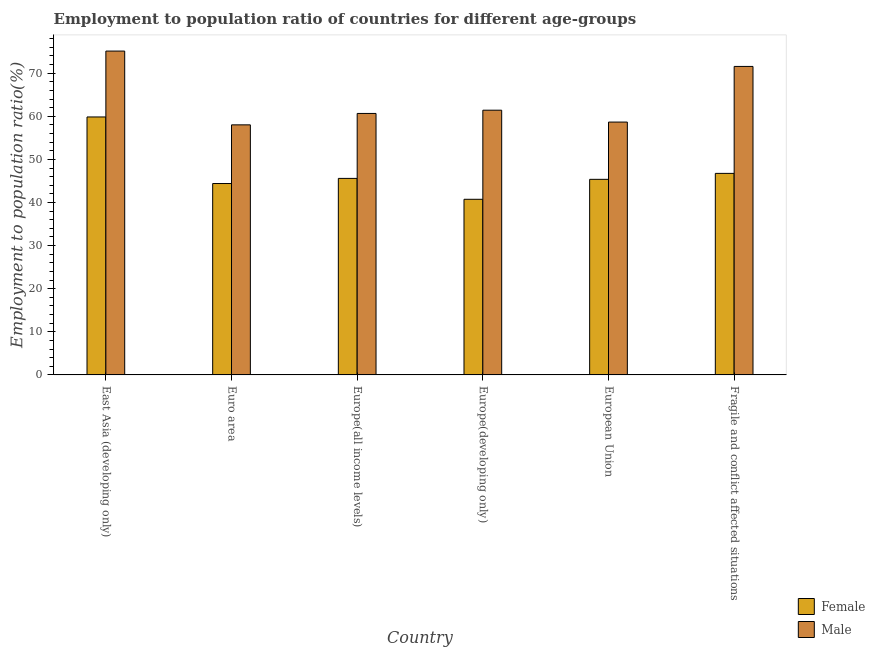How many different coloured bars are there?
Give a very brief answer. 2. Are the number of bars on each tick of the X-axis equal?
Ensure brevity in your answer.  Yes. How many bars are there on the 2nd tick from the right?
Your response must be concise. 2. What is the label of the 4th group of bars from the left?
Keep it short and to the point. Europe(developing only). What is the employment to population ratio(female) in Euro area?
Your response must be concise. 44.4. Across all countries, what is the maximum employment to population ratio(female)?
Make the answer very short. 59.85. Across all countries, what is the minimum employment to population ratio(female)?
Your answer should be very brief. 40.74. In which country was the employment to population ratio(male) maximum?
Offer a very short reply. East Asia (developing only). In which country was the employment to population ratio(male) minimum?
Make the answer very short. Euro area. What is the total employment to population ratio(male) in the graph?
Provide a short and direct response. 385.44. What is the difference between the employment to population ratio(female) in East Asia (developing only) and that in Europe(developing only)?
Keep it short and to the point. 19.1. What is the difference between the employment to population ratio(female) in Europe(all income levels) and the employment to population ratio(male) in Fragile and conflict affected situations?
Your answer should be very brief. -25.97. What is the average employment to population ratio(male) per country?
Ensure brevity in your answer.  64.24. What is the difference between the employment to population ratio(male) and employment to population ratio(female) in Fragile and conflict affected situations?
Offer a terse response. 24.81. In how many countries, is the employment to population ratio(female) greater than 52 %?
Offer a very short reply. 1. What is the ratio of the employment to population ratio(male) in Euro area to that in European Union?
Ensure brevity in your answer.  0.99. Is the employment to population ratio(male) in Europe(all income levels) less than that in Fragile and conflict affected situations?
Provide a short and direct response. Yes. What is the difference between the highest and the second highest employment to population ratio(male)?
Provide a succinct answer. 3.56. What is the difference between the highest and the lowest employment to population ratio(male)?
Make the answer very short. 17.12. Is the sum of the employment to population ratio(male) in Europe(developing only) and Fragile and conflict affected situations greater than the maximum employment to population ratio(female) across all countries?
Make the answer very short. Yes. How many countries are there in the graph?
Provide a short and direct response. 6. What is the difference between two consecutive major ticks on the Y-axis?
Keep it short and to the point. 10. Are the values on the major ticks of Y-axis written in scientific E-notation?
Your answer should be compact. No. Does the graph contain any zero values?
Your answer should be very brief. No. Where does the legend appear in the graph?
Provide a succinct answer. Bottom right. How are the legend labels stacked?
Ensure brevity in your answer.  Vertical. What is the title of the graph?
Give a very brief answer. Employment to population ratio of countries for different age-groups. What is the label or title of the X-axis?
Ensure brevity in your answer.  Country. What is the Employment to population ratio(%) in Female in East Asia (developing only)?
Provide a succinct answer. 59.85. What is the Employment to population ratio(%) in Male in East Asia (developing only)?
Offer a very short reply. 75.13. What is the Employment to population ratio(%) in Female in Euro area?
Provide a short and direct response. 44.4. What is the Employment to population ratio(%) of Male in Euro area?
Your answer should be compact. 58.01. What is the Employment to population ratio(%) in Female in Europe(all income levels)?
Offer a terse response. 45.59. What is the Employment to population ratio(%) of Male in Europe(all income levels)?
Ensure brevity in your answer.  60.66. What is the Employment to population ratio(%) in Female in Europe(developing only)?
Keep it short and to the point. 40.74. What is the Employment to population ratio(%) of Male in Europe(developing only)?
Provide a succinct answer. 61.41. What is the Employment to population ratio(%) in Female in European Union?
Provide a short and direct response. 45.37. What is the Employment to population ratio(%) in Male in European Union?
Your answer should be compact. 58.66. What is the Employment to population ratio(%) in Female in Fragile and conflict affected situations?
Offer a terse response. 46.75. What is the Employment to population ratio(%) in Male in Fragile and conflict affected situations?
Provide a short and direct response. 71.57. Across all countries, what is the maximum Employment to population ratio(%) in Female?
Offer a terse response. 59.85. Across all countries, what is the maximum Employment to population ratio(%) of Male?
Provide a short and direct response. 75.13. Across all countries, what is the minimum Employment to population ratio(%) in Female?
Your answer should be very brief. 40.74. Across all countries, what is the minimum Employment to population ratio(%) in Male?
Offer a very short reply. 58.01. What is the total Employment to population ratio(%) of Female in the graph?
Offer a very short reply. 282.71. What is the total Employment to population ratio(%) in Male in the graph?
Your answer should be very brief. 385.44. What is the difference between the Employment to population ratio(%) of Female in East Asia (developing only) and that in Euro area?
Provide a short and direct response. 15.44. What is the difference between the Employment to population ratio(%) of Male in East Asia (developing only) and that in Euro area?
Offer a very short reply. 17.12. What is the difference between the Employment to population ratio(%) of Female in East Asia (developing only) and that in Europe(all income levels)?
Your response must be concise. 14.25. What is the difference between the Employment to population ratio(%) in Male in East Asia (developing only) and that in Europe(all income levels)?
Your answer should be compact. 14.47. What is the difference between the Employment to population ratio(%) in Female in East Asia (developing only) and that in Europe(developing only)?
Provide a short and direct response. 19.1. What is the difference between the Employment to population ratio(%) in Male in East Asia (developing only) and that in Europe(developing only)?
Make the answer very short. 13.72. What is the difference between the Employment to population ratio(%) in Female in East Asia (developing only) and that in European Union?
Make the answer very short. 14.47. What is the difference between the Employment to population ratio(%) in Male in East Asia (developing only) and that in European Union?
Offer a terse response. 16.47. What is the difference between the Employment to population ratio(%) of Female in East Asia (developing only) and that in Fragile and conflict affected situations?
Provide a short and direct response. 13.09. What is the difference between the Employment to population ratio(%) of Male in East Asia (developing only) and that in Fragile and conflict affected situations?
Offer a terse response. 3.56. What is the difference between the Employment to population ratio(%) of Female in Euro area and that in Europe(all income levels)?
Provide a short and direct response. -1.19. What is the difference between the Employment to population ratio(%) of Male in Euro area and that in Europe(all income levels)?
Provide a succinct answer. -2.65. What is the difference between the Employment to population ratio(%) of Female in Euro area and that in Europe(developing only)?
Keep it short and to the point. 3.66. What is the difference between the Employment to population ratio(%) in Male in Euro area and that in Europe(developing only)?
Offer a very short reply. -3.4. What is the difference between the Employment to population ratio(%) in Female in Euro area and that in European Union?
Give a very brief answer. -0.97. What is the difference between the Employment to population ratio(%) of Male in Euro area and that in European Union?
Your answer should be very brief. -0.65. What is the difference between the Employment to population ratio(%) in Female in Euro area and that in Fragile and conflict affected situations?
Your answer should be compact. -2.35. What is the difference between the Employment to population ratio(%) of Male in Euro area and that in Fragile and conflict affected situations?
Make the answer very short. -13.55. What is the difference between the Employment to population ratio(%) of Female in Europe(all income levels) and that in Europe(developing only)?
Your answer should be very brief. 4.85. What is the difference between the Employment to population ratio(%) of Male in Europe(all income levels) and that in Europe(developing only)?
Ensure brevity in your answer.  -0.75. What is the difference between the Employment to population ratio(%) in Female in Europe(all income levels) and that in European Union?
Provide a succinct answer. 0.22. What is the difference between the Employment to population ratio(%) of Male in Europe(all income levels) and that in European Union?
Your response must be concise. 2. What is the difference between the Employment to population ratio(%) of Female in Europe(all income levels) and that in Fragile and conflict affected situations?
Your response must be concise. -1.16. What is the difference between the Employment to population ratio(%) in Male in Europe(all income levels) and that in Fragile and conflict affected situations?
Provide a succinct answer. -10.91. What is the difference between the Employment to population ratio(%) in Female in Europe(developing only) and that in European Union?
Your answer should be compact. -4.63. What is the difference between the Employment to population ratio(%) of Male in Europe(developing only) and that in European Union?
Your answer should be compact. 2.75. What is the difference between the Employment to population ratio(%) of Female in Europe(developing only) and that in Fragile and conflict affected situations?
Your answer should be very brief. -6.01. What is the difference between the Employment to population ratio(%) in Male in Europe(developing only) and that in Fragile and conflict affected situations?
Keep it short and to the point. -10.15. What is the difference between the Employment to population ratio(%) of Female in European Union and that in Fragile and conflict affected situations?
Your answer should be compact. -1.38. What is the difference between the Employment to population ratio(%) of Male in European Union and that in Fragile and conflict affected situations?
Provide a short and direct response. -12.91. What is the difference between the Employment to population ratio(%) in Female in East Asia (developing only) and the Employment to population ratio(%) in Male in Euro area?
Keep it short and to the point. 1.83. What is the difference between the Employment to population ratio(%) in Female in East Asia (developing only) and the Employment to population ratio(%) in Male in Europe(all income levels)?
Keep it short and to the point. -0.81. What is the difference between the Employment to population ratio(%) of Female in East Asia (developing only) and the Employment to population ratio(%) of Male in Europe(developing only)?
Offer a very short reply. -1.57. What is the difference between the Employment to population ratio(%) of Female in East Asia (developing only) and the Employment to population ratio(%) of Male in European Union?
Offer a very short reply. 1.19. What is the difference between the Employment to population ratio(%) in Female in East Asia (developing only) and the Employment to population ratio(%) in Male in Fragile and conflict affected situations?
Your answer should be compact. -11.72. What is the difference between the Employment to population ratio(%) of Female in Euro area and the Employment to population ratio(%) of Male in Europe(all income levels)?
Your response must be concise. -16.26. What is the difference between the Employment to population ratio(%) in Female in Euro area and the Employment to population ratio(%) in Male in Europe(developing only)?
Ensure brevity in your answer.  -17.01. What is the difference between the Employment to population ratio(%) in Female in Euro area and the Employment to population ratio(%) in Male in European Union?
Offer a very short reply. -14.26. What is the difference between the Employment to population ratio(%) of Female in Euro area and the Employment to population ratio(%) of Male in Fragile and conflict affected situations?
Your response must be concise. -27.16. What is the difference between the Employment to population ratio(%) in Female in Europe(all income levels) and the Employment to population ratio(%) in Male in Europe(developing only)?
Provide a short and direct response. -15.82. What is the difference between the Employment to population ratio(%) in Female in Europe(all income levels) and the Employment to population ratio(%) in Male in European Union?
Your response must be concise. -13.07. What is the difference between the Employment to population ratio(%) of Female in Europe(all income levels) and the Employment to population ratio(%) of Male in Fragile and conflict affected situations?
Your response must be concise. -25.97. What is the difference between the Employment to population ratio(%) of Female in Europe(developing only) and the Employment to population ratio(%) of Male in European Union?
Keep it short and to the point. -17.91. What is the difference between the Employment to population ratio(%) in Female in Europe(developing only) and the Employment to population ratio(%) in Male in Fragile and conflict affected situations?
Your answer should be very brief. -30.82. What is the difference between the Employment to population ratio(%) in Female in European Union and the Employment to population ratio(%) in Male in Fragile and conflict affected situations?
Give a very brief answer. -26.19. What is the average Employment to population ratio(%) of Female per country?
Keep it short and to the point. 47.12. What is the average Employment to population ratio(%) of Male per country?
Provide a succinct answer. 64.24. What is the difference between the Employment to population ratio(%) in Female and Employment to population ratio(%) in Male in East Asia (developing only)?
Offer a terse response. -15.29. What is the difference between the Employment to population ratio(%) of Female and Employment to population ratio(%) of Male in Euro area?
Provide a short and direct response. -13.61. What is the difference between the Employment to population ratio(%) of Female and Employment to population ratio(%) of Male in Europe(all income levels)?
Your answer should be very brief. -15.07. What is the difference between the Employment to population ratio(%) in Female and Employment to population ratio(%) in Male in Europe(developing only)?
Your answer should be very brief. -20.67. What is the difference between the Employment to population ratio(%) of Female and Employment to population ratio(%) of Male in European Union?
Your answer should be very brief. -13.29. What is the difference between the Employment to population ratio(%) in Female and Employment to population ratio(%) in Male in Fragile and conflict affected situations?
Your answer should be compact. -24.81. What is the ratio of the Employment to population ratio(%) of Female in East Asia (developing only) to that in Euro area?
Offer a very short reply. 1.35. What is the ratio of the Employment to population ratio(%) of Male in East Asia (developing only) to that in Euro area?
Your response must be concise. 1.3. What is the ratio of the Employment to population ratio(%) in Female in East Asia (developing only) to that in Europe(all income levels)?
Provide a succinct answer. 1.31. What is the ratio of the Employment to population ratio(%) in Male in East Asia (developing only) to that in Europe(all income levels)?
Offer a very short reply. 1.24. What is the ratio of the Employment to population ratio(%) in Female in East Asia (developing only) to that in Europe(developing only)?
Provide a short and direct response. 1.47. What is the ratio of the Employment to population ratio(%) of Male in East Asia (developing only) to that in Europe(developing only)?
Make the answer very short. 1.22. What is the ratio of the Employment to population ratio(%) in Female in East Asia (developing only) to that in European Union?
Give a very brief answer. 1.32. What is the ratio of the Employment to population ratio(%) of Male in East Asia (developing only) to that in European Union?
Make the answer very short. 1.28. What is the ratio of the Employment to population ratio(%) in Female in East Asia (developing only) to that in Fragile and conflict affected situations?
Offer a terse response. 1.28. What is the ratio of the Employment to population ratio(%) of Male in East Asia (developing only) to that in Fragile and conflict affected situations?
Provide a short and direct response. 1.05. What is the ratio of the Employment to population ratio(%) of Female in Euro area to that in Europe(all income levels)?
Give a very brief answer. 0.97. What is the ratio of the Employment to population ratio(%) in Male in Euro area to that in Europe(all income levels)?
Your response must be concise. 0.96. What is the ratio of the Employment to population ratio(%) of Female in Euro area to that in Europe(developing only)?
Ensure brevity in your answer.  1.09. What is the ratio of the Employment to population ratio(%) of Male in Euro area to that in Europe(developing only)?
Offer a terse response. 0.94. What is the ratio of the Employment to population ratio(%) of Female in Euro area to that in European Union?
Your answer should be very brief. 0.98. What is the ratio of the Employment to population ratio(%) in Male in Euro area to that in European Union?
Keep it short and to the point. 0.99. What is the ratio of the Employment to population ratio(%) of Female in Euro area to that in Fragile and conflict affected situations?
Offer a terse response. 0.95. What is the ratio of the Employment to population ratio(%) in Male in Euro area to that in Fragile and conflict affected situations?
Offer a very short reply. 0.81. What is the ratio of the Employment to population ratio(%) in Female in Europe(all income levels) to that in Europe(developing only)?
Give a very brief answer. 1.12. What is the ratio of the Employment to population ratio(%) of Male in Europe(all income levels) to that in Europe(developing only)?
Offer a very short reply. 0.99. What is the ratio of the Employment to population ratio(%) of Female in Europe(all income levels) to that in European Union?
Your response must be concise. 1. What is the ratio of the Employment to population ratio(%) in Male in Europe(all income levels) to that in European Union?
Make the answer very short. 1.03. What is the ratio of the Employment to population ratio(%) of Female in Europe(all income levels) to that in Fragile and conflict affected situations?
Ensure brevity in your answer.  0.98. What is the ratio of the Employment to population ratio(%) of Male in Europe(all income levels) to that in Fragile and conflict affected situations?
Ensure brevity in your answer.  0.85. What is the ratio of the Employment to population ratio(%) in Female in Europe(developing only) to that in European Union?
Offer a terse response. 0.9. What is the ratio of the Employment to population ratio(%) of Male in Europe(developing only) to that in European Union?
Keep it short and to the point. 1.05. What is the ratio of the Employment to population ratio(%) of Female in Europe(developing only) to that in Fragile and conflict affected situations?
Offer a terse response. 0.87. What is the ratio of the Employment to population ratio(%) in Male in Europe(developing only) to that in Fragile and conflict affected situations?
Offer a terse response. 0.86. What is the ratio of the Employment to population ratio(%) of Female in European Union to that in Fragile and conflict affected situations?
Provide a succinct answer. 0.97. What is the ratio of the Employment to population ratio(%) of Male in European Union to that in Fragile and conflict affected situations?
Give a very brief answer. 0.82. What is the difference between the highest and the second highest Employment to population ratio(%) of Female?
Your response must be concise. 13.09. What is the difference between the highest and the second highest Employment to population ratio(%) in Male?
Your response must be concise. 3.56. What is the difference between the highest and the lowest Employment to population ratio(%) of Female?
Give a very brief answer. 19.1. What is the difference between the highest and the lowest Employment to population ratio(%) of Male?
Keep it short and to the point. 17.12. 